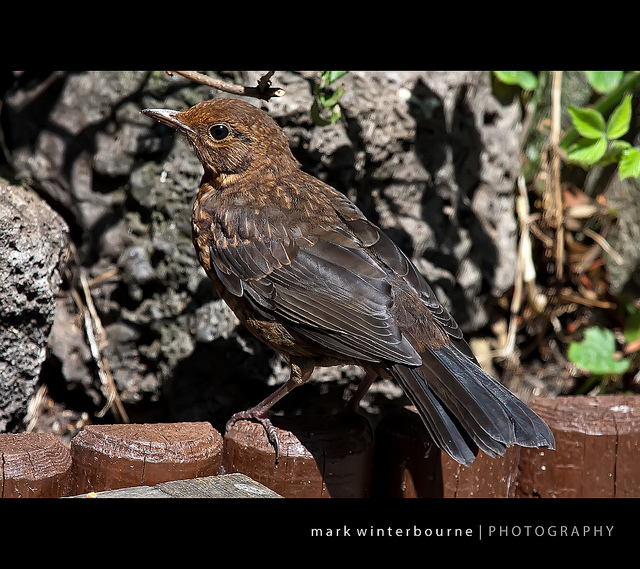Identify the text contained in this image. mark winterbourne PHOTOGRAPHY 